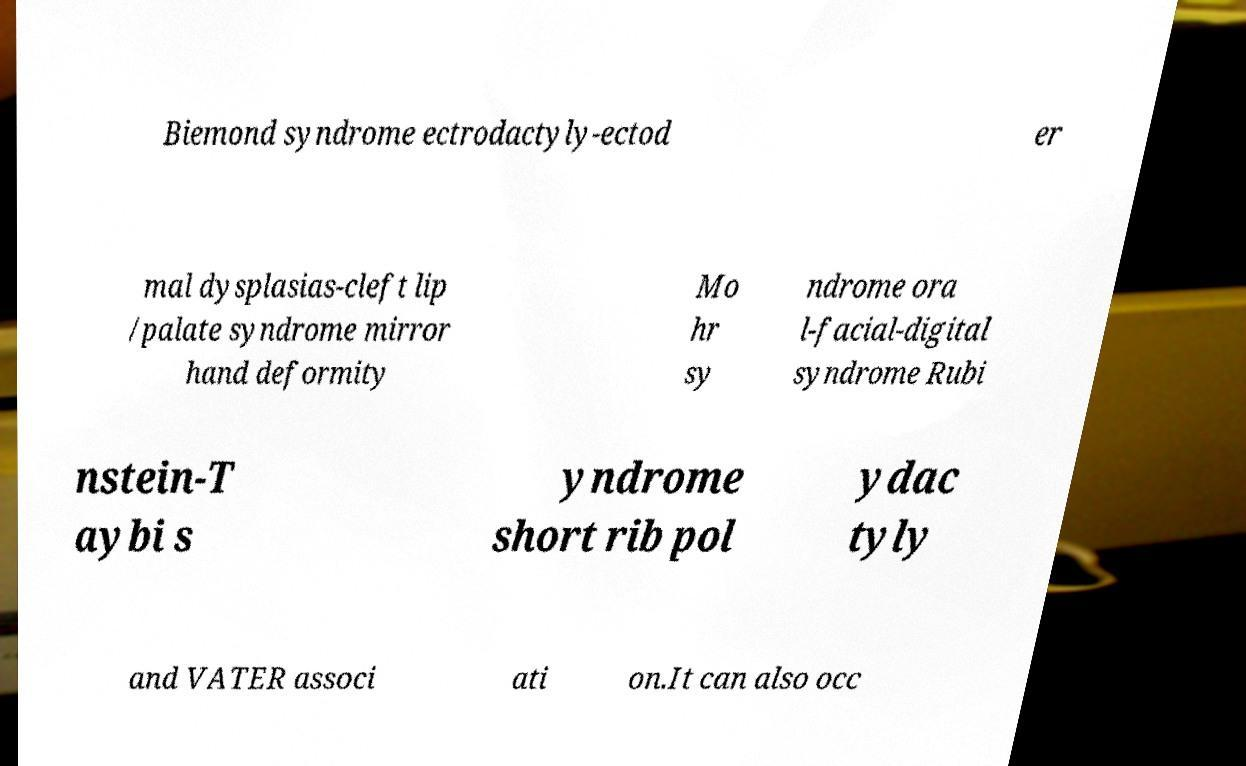Could you assist in decoding the text presented in this image and type it out clearly? Biemond syndrome ectrodactyly-ectod er mal dysplasias-cleft lip /palate syndrome mirror hand deformity Mo hr sy ndrome ora l-facial-digital syndrome Rubi nstein-T aybi s yndrome short rib pol ydac tyly and VATER associ ati on.It can also occ 